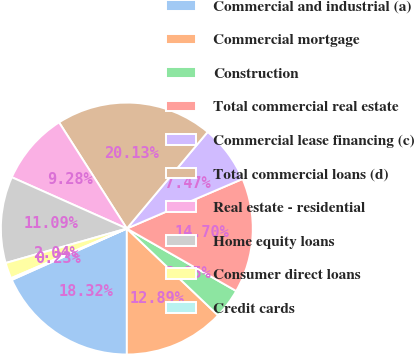Convert chart. <chart><loc_0><loc_0><loc_500><loc_500><pie_chart><fcel>Commercial and industrial (a)<fcel>Commercial mortgage<fcel>Construction<fcel>Total commercial real estate<fcel>Commercial lease financing (c)<fcel>Total commercial loans (d)<fcel>Real estate - residential<fcel>Home equity loans<fcel>Consumer direct loans<fcel>Credit cards<nl><fcel>18.32%<fcel>12.89%<fcel>3.85%<fcel>14.7%<fcel>7.47%<fcel>20.13%<fcel>9.28%<fcel>11.09%<fcel>2.04%<fcel>0.23%<nl></chart> 